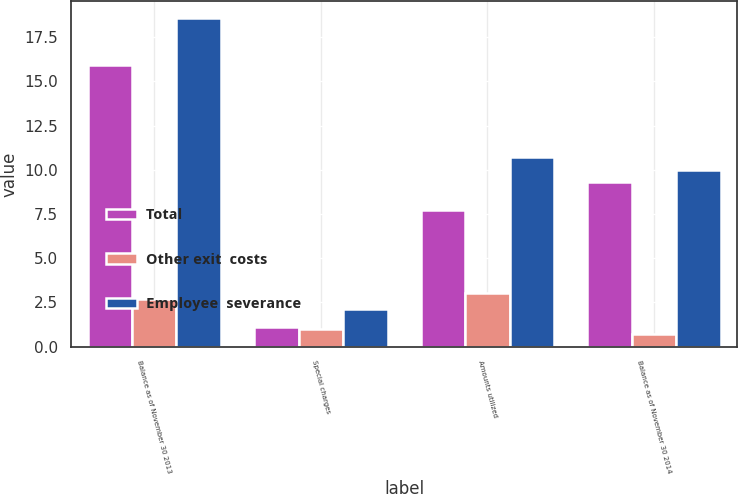Convert chart to OTSL. <chart><loc_0><loc_0><loc_500><loc_500><stacked_bar_chart><ecel><fcel>Balance as of November 30 2013<fcel>Special charges<fcel>Amounts utilized<fcel>Balance as of November 30 2014<nl><fcel>Total<fcel>15.9<fcel>1.1<fcel>7.7<fcel>9.3<nl><fcel>Other exit  costs<fcel>2.7<fcel>1<fcel>3<fcel>0.7<nl><fcel>Employee  severance<fcel>18.6<fcel>2.1<fcel>10.7<fcel>10<nl></chart> 